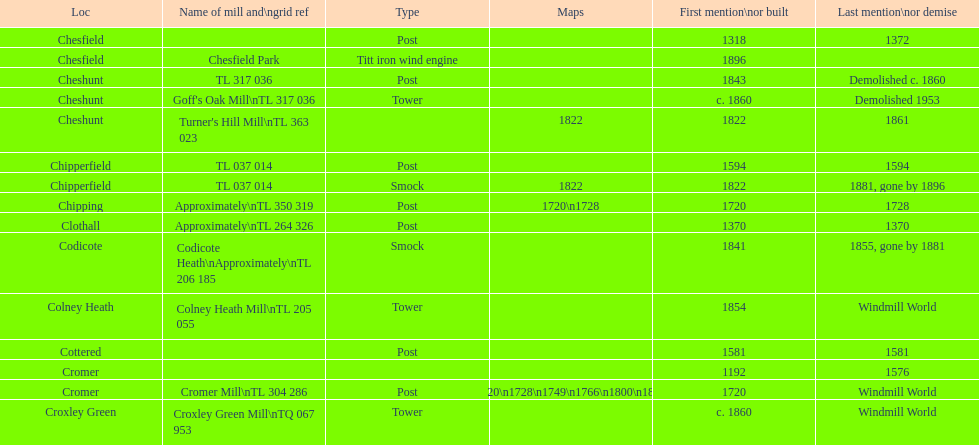Would you be able to parse every entry in this table? {'header': ['Loc', 'Name of mill and\\ngrid ref', 'Type', 'Maps', 'First mention\\nor built', 'Last mention\\nor demise'], 'rows': [['Chesfield', '', 'Post', '', '1318', '1372'], ['Chesfield', 'Chesfield Park', 'Titt iron wind engine', '', '1896', ''], ['Cheshunt', 'TL 317 036', 'Post', '', '1843', 'Demolished c. 1860'], ['Cheshunt', "Goff's Oak Mill\\nTL 317 036", 'Tower', '', 'c. 1860', 'Demolished 1953'], ['Cheshunt', "Turner's Hill Mill\\nTL 363 023", '', '1822', '1822', '1861'], ['Chipperfield', 'TL 037 014', 'Post', '', '1594', '1594'], ['Chipperfield', 'TL 037 014', 'Smock', '1822', '1822', '1881, gone by 1896'], ['Chipping', 'Approximately\\nTL 350 319', 'Post', '1720\\n1728', '1720', '1728'], ['Clothall', 'Approximately\\nTL 264 326', 'Post', '', '1370', '1370'], ['Codicote', 'Codicote Heath\\nApproximately\\nTL 206 185', 'Smock', '', '1841', '1855, gone by 1881'], ['Colney Heath', 'Colney Heath Mill\\nTL 205 055', 'Tower', '', '1854', 'Windmill World'], ['Cottered', '', 'Post', '', '1581', '1581'], ['Cromer', '', '', '', '1192', '1576'], ['Cromer', 'Cromer Mill\\nTL 304 286', 'Post', '1720\\n1728\\n1749\\n1766\\n1800\\n1822', '1720', 'Windmill World'], ['Croxley Green', 'Croxley Green Mill\\nTQ 067 953', 'Tower', '', 'c. 1860', 'Windmill World']]} What is the count of mills first referenced or built in the 1800s? 8. 